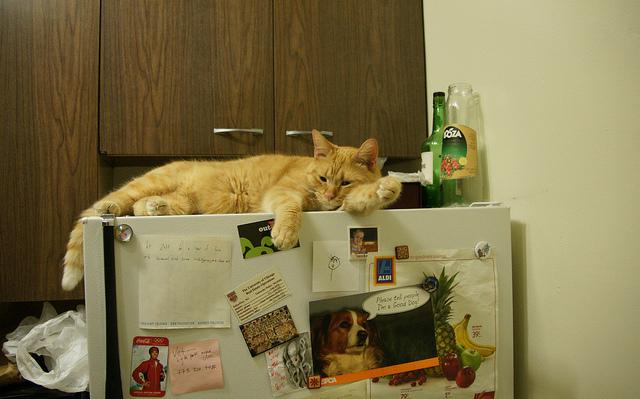Is the tail fluffy?
Concise answer only. Yes. Is the cat comfortable?
Answer briefly. Yes. What animal is this?
Short answer required. Cat. What is on the fridge?
Be succinct. Cat. Is the cat on top of a car?
Answer briefly. No. 